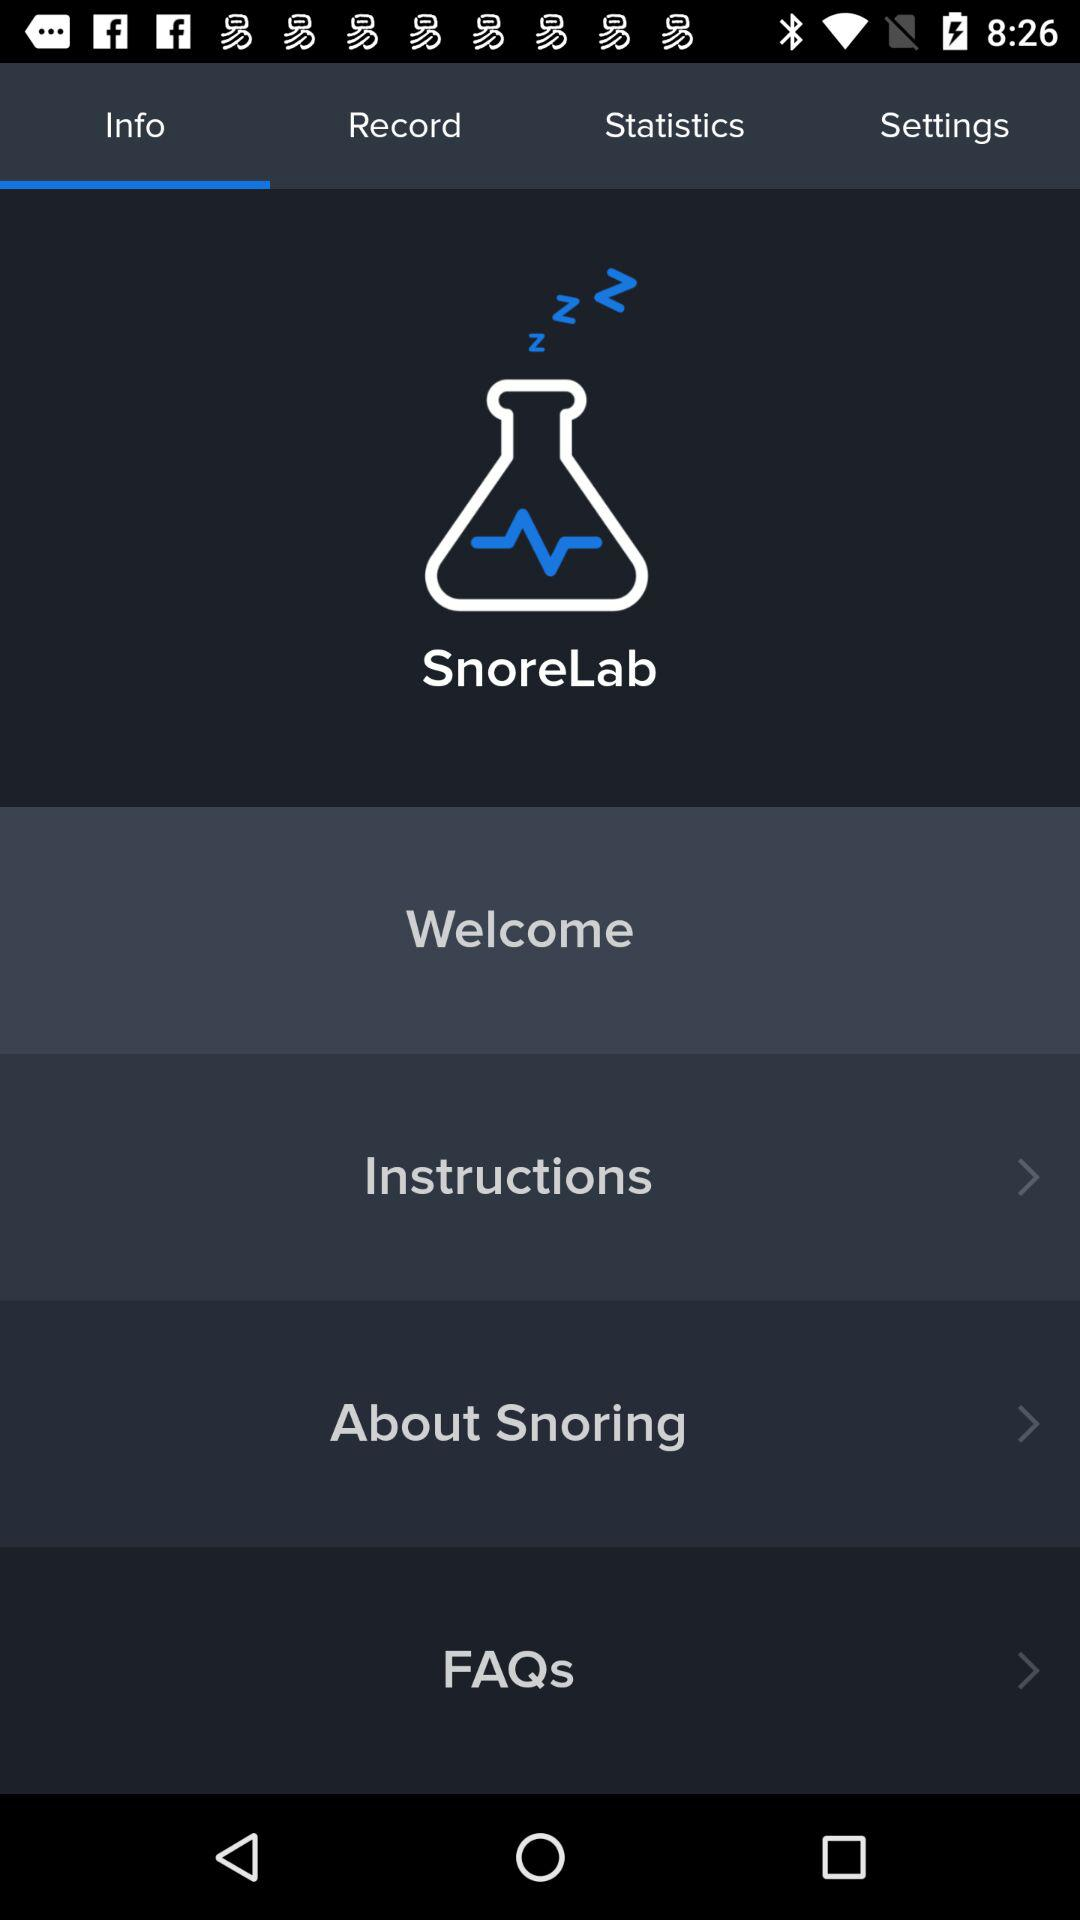Which option is selected? The selected option is "Info". 